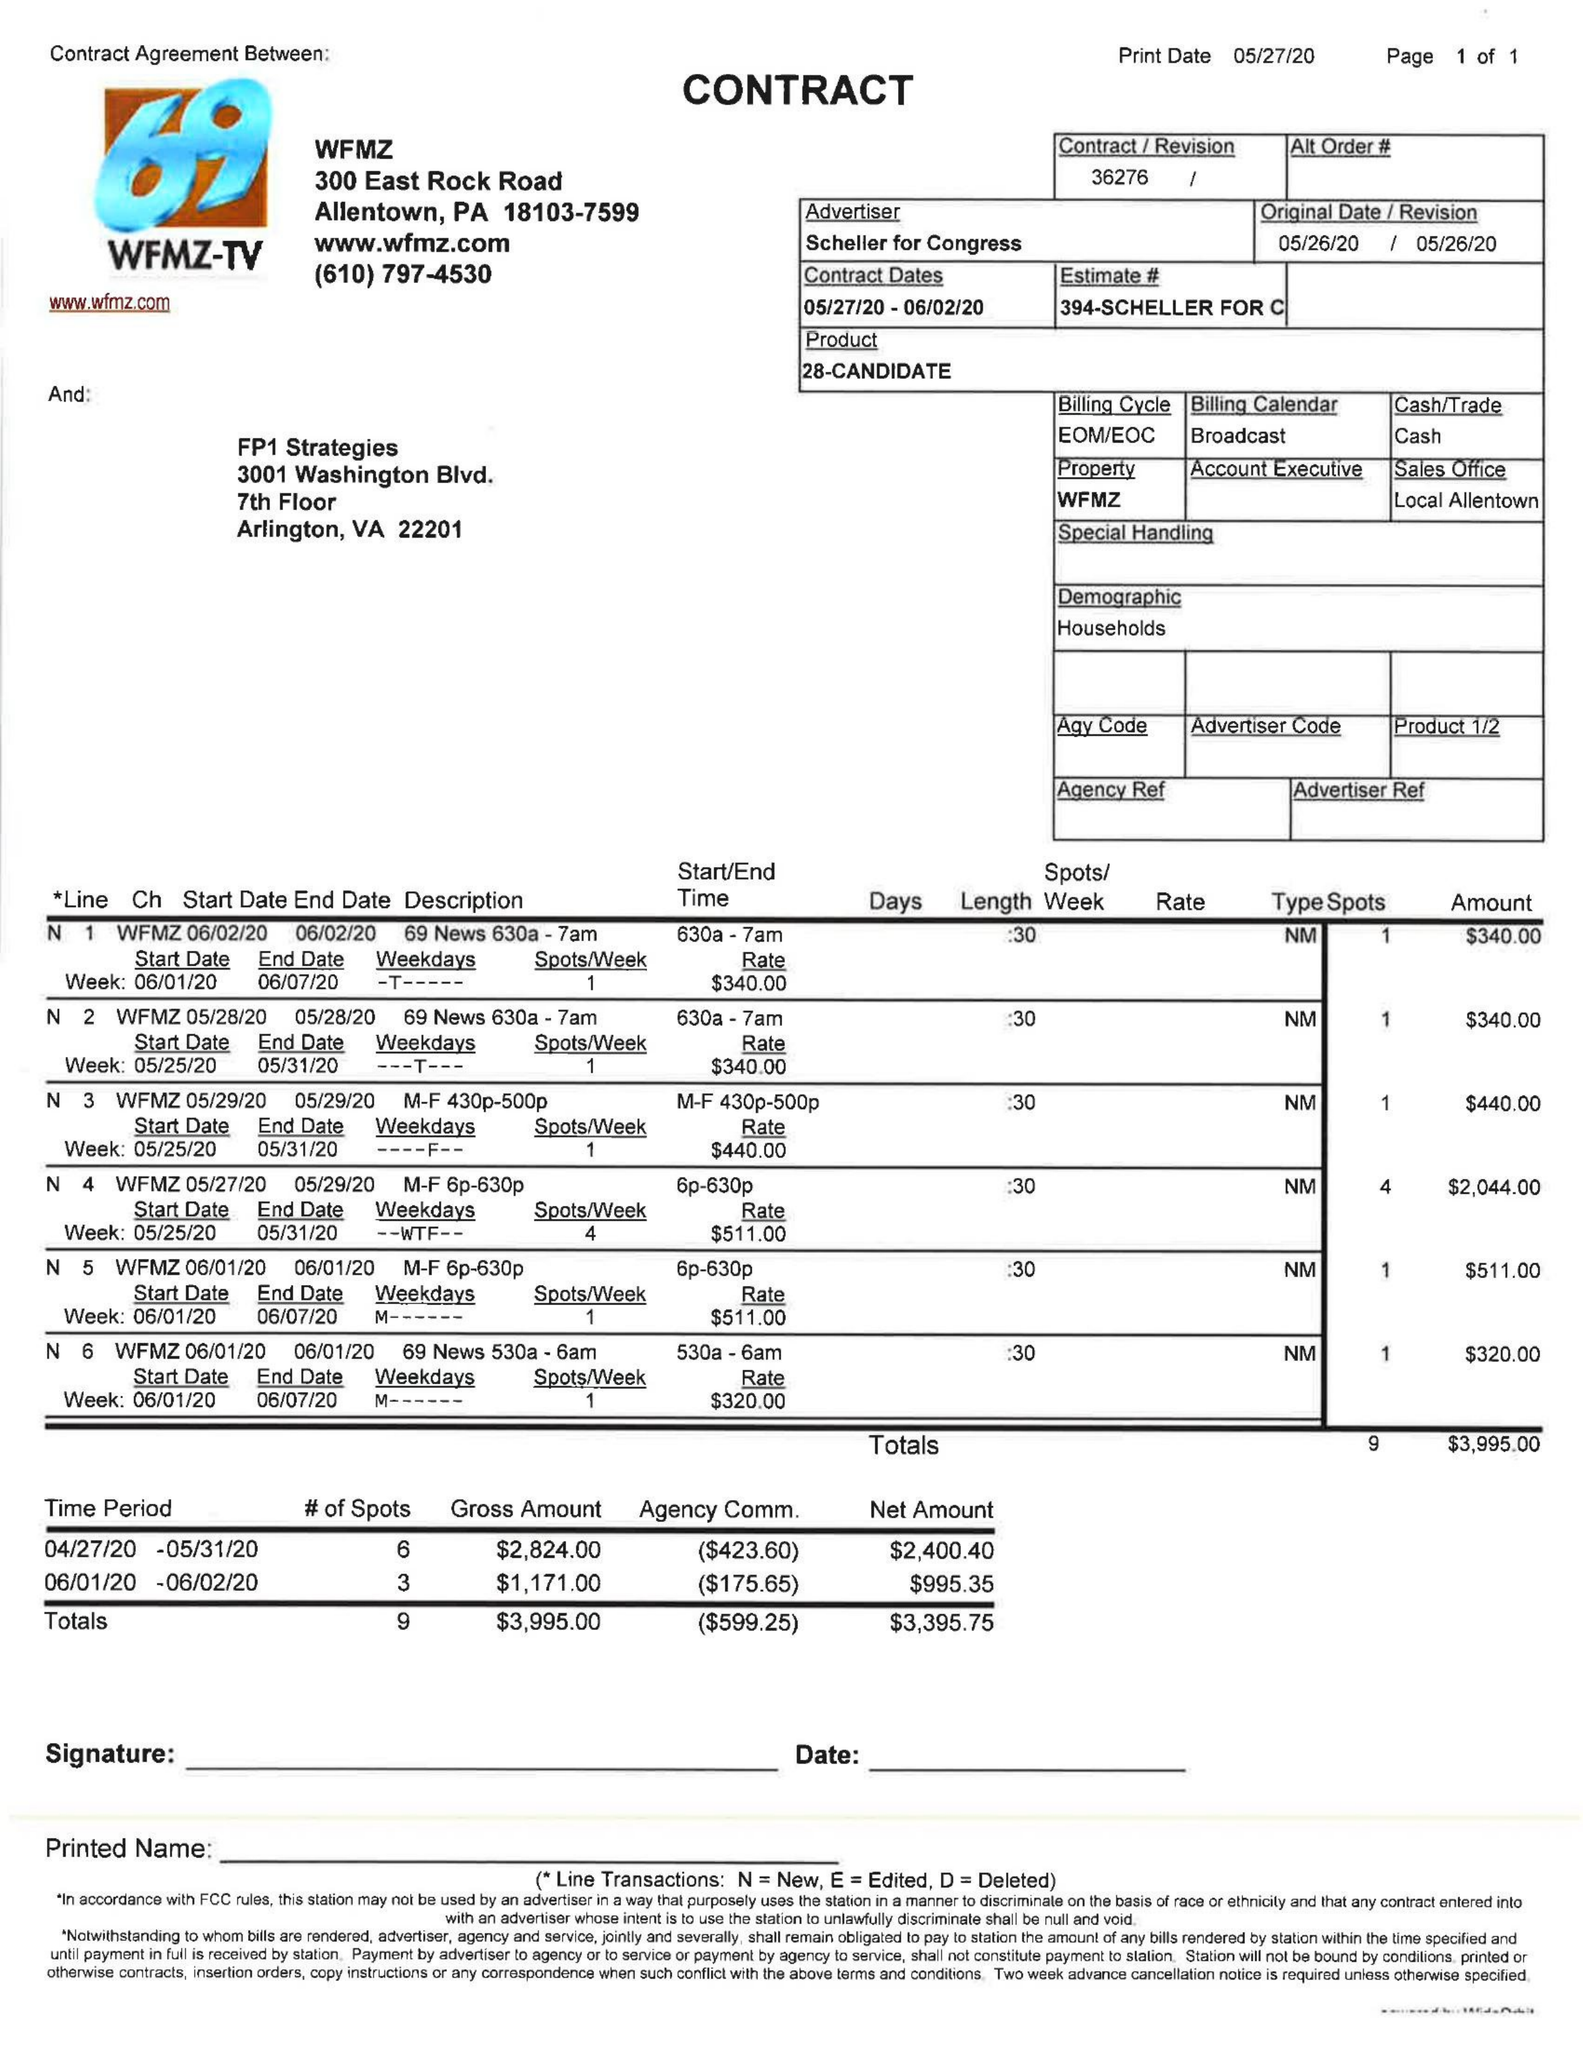What is the value for the flight_from?
Answer the question using a single word or phrase. 05/27/20 